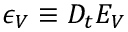Convert formula to latex. <formula><loc_0><loc_0><loc_500><loc_500>\epsilon _ { V } \equiv D _ { t } E _ { V }</formula> 